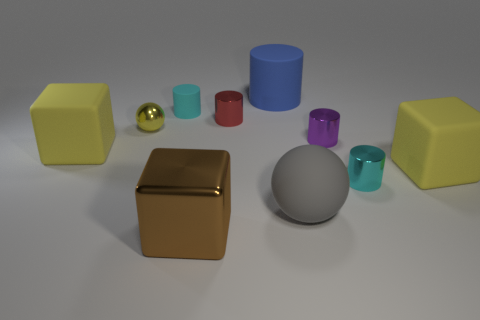Subtract all metallic cubes. How many cubes are left? 2 Subtract 2 blocks. How many blocks are left? 1 Subtract all brown cubes. How many cubes are left? 2 Subtract all blue blocks. Subtract all red spheres. How many blocks are left? 3 Subtract all green cylinders. How many yellow blocks are left? 2 Subtract all large gray objects. Subtract all rubber blocks. How many objects are left? 7 Add 5 large rubber objects. How many large rubber objects are left? 9 Add 9 shiny blocks. How many shiny blocks exist? 10 Subtract 1 brown cubes. How many objects are left? 9 Subtract all balls. How many objects are left? 8 